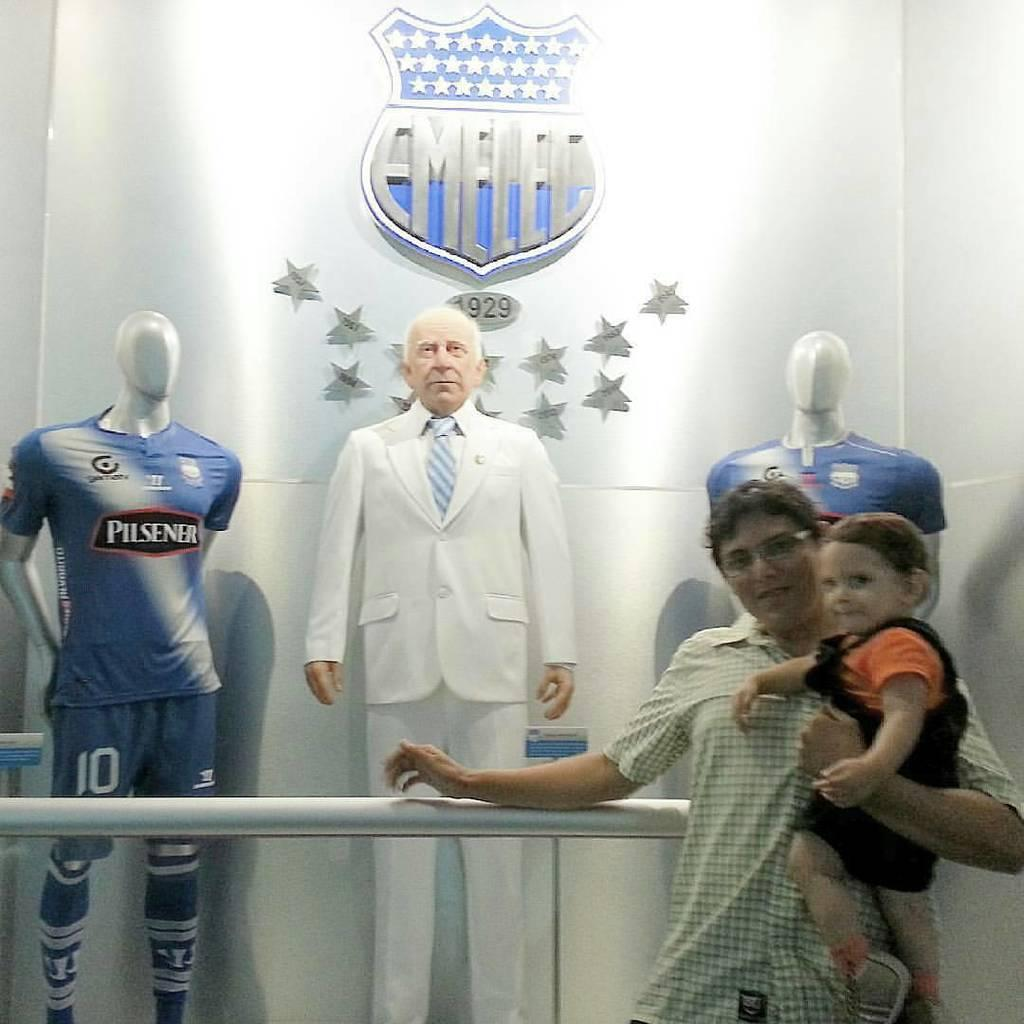<image>
Relay a brief, clear account of the picture shown. A man and his son at a wax museum showing a person from pilsener. 